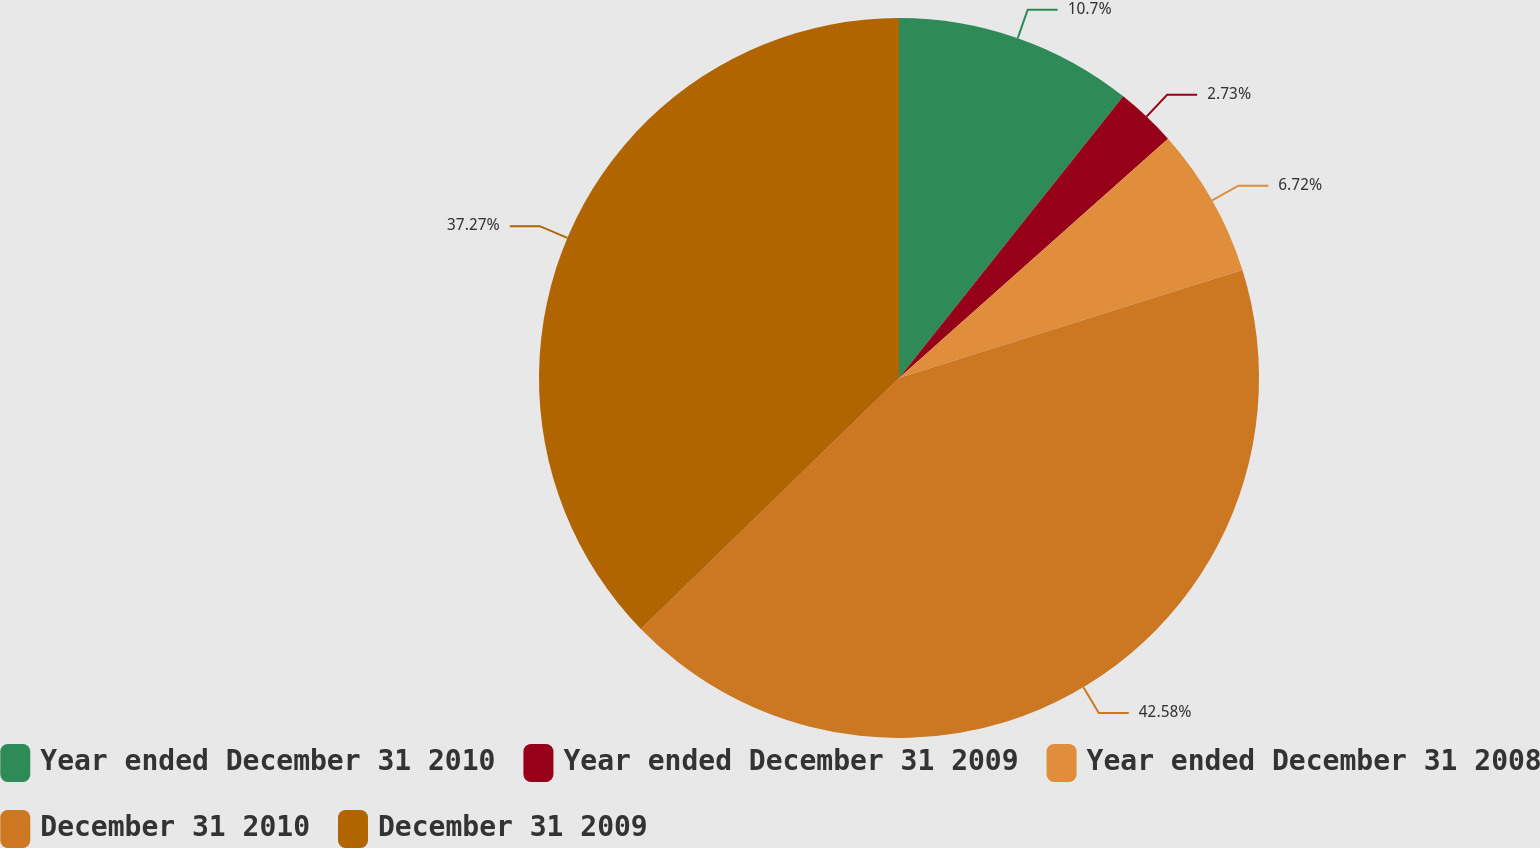<chart> <loc_0><loc_0><loc_500><loc_500><pie_chart><fcel>Year ended December 31 2010<fcel>Year ended December 31 2009<fcel>Year ended December 31 2008<fcel>December 31 2010<fcel>December 31 2009<nl><fcel>10.7%<fcel>2.73%<fcel>6.72%<fcel>42.57%<fcel>37.27%<nl></chart> 